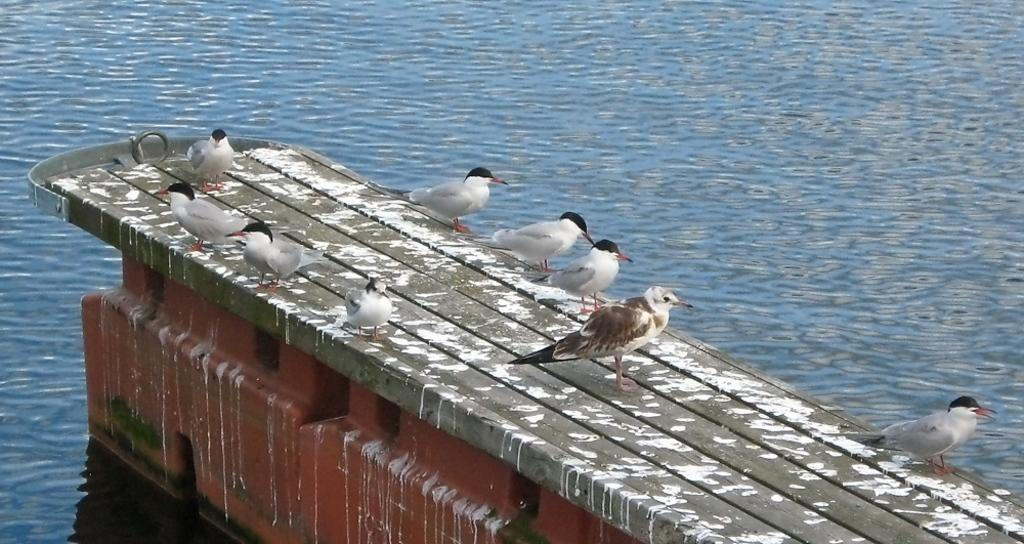What type of animals can be seen in the image? There are birds on the surface in the image. What is the primary element in which the birds are situated? The birds are situated on the surface of water, which is visible in the image. Where is the kitten playing with a spring in the image? There is no kitten or spring present in the image; it features birds on the surface of water. What type of goat can be seen grazing in the image? There is no goat present in the image; it features birds on the surface of water. 